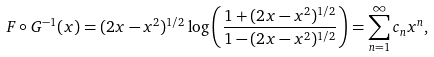<formula> <loc_0><loc_0><loc_500><loc_500>F \circ G ^ { - 1 } ( x ) = ( 2 x - x ^ { 2 } ) ^ { 1 / 2 } \log \left ( \frac { 1 + ( 2 x - x ^ { 2 } ) ^ { 1 / 2 } } { 1 - ( 2 x - x ^ { 2 } ) ^ { 1 / 2 } } \right ) = \sum _ { n = 1 } ^ { \infty } c _ { n } x ^ { n } ,</formula> 